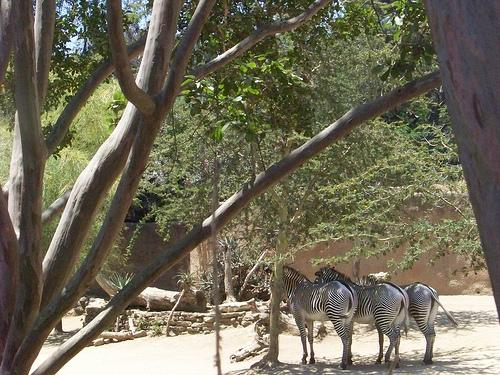List three prominent objects or features found in the image. Group of zebras, curved trunk laying on its side, tan wall of enclosure in the background. Provide a brief overview of the main elements in the image. Three zebras with various tail positions stand side by side in an enclosure under a tree, near a log on a low wall and a tan wall behind them. Describe the legs and tails of the zebras in the image. The zebras' legs are planted firmly on the ground, while their tails are held in distinct directions, showing their unique styles. Describe the positions and styles of the zebra tails in the image. One zebra's tail curves west, another points directly south, and the third tail goes off at an eastern 45-degree angle. Mention the primary subject of the image and their action. Butt ends of three zebras, each having their tails pointing in different directions. Describe the setting and atmosphere of the image. An enclosure with zebras, trees, and branches overhead, creating shade with a blue sky seen through leaves. In one sentence, explain the main focus of the image. The image highlights the tail ends of three zebras standing together with unique tail positions. Describe the image using only adjectives and prepositions. Striped, various, tail-end, shaded, leafy, wooden, curved, blue-skied, tan-walled, side-by-side. Illustrate a scene from the photograph by describing the positions of the primary characters. Under the protective branches of a tree, three zebras with contrasting sizes huddle together, each flaunting its tail in a unique posture. Write a short and poetic description of the image. Under a canopy of leaves, three striped companions stand side by side, tails aloft like flags in the breeze. 